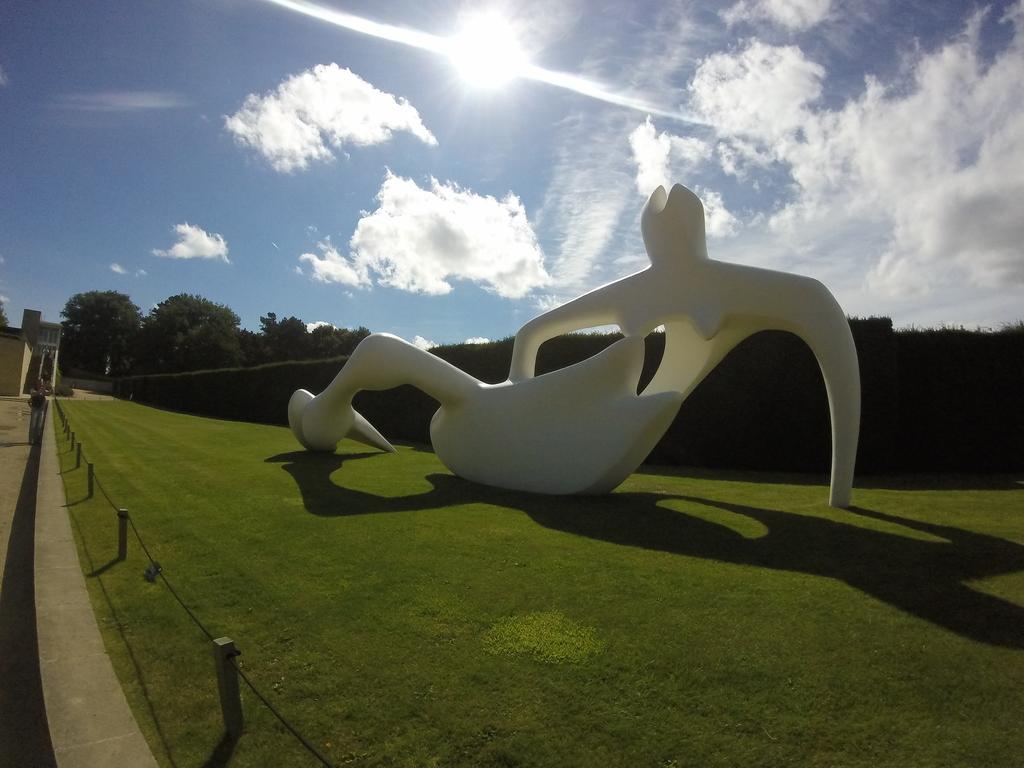How would you summarize this image in a sentence or two? In this picture we can observe a white color object placed on the ground. There is some grass on the ground. In the background there are trees and a sky with clouds and a sun. 